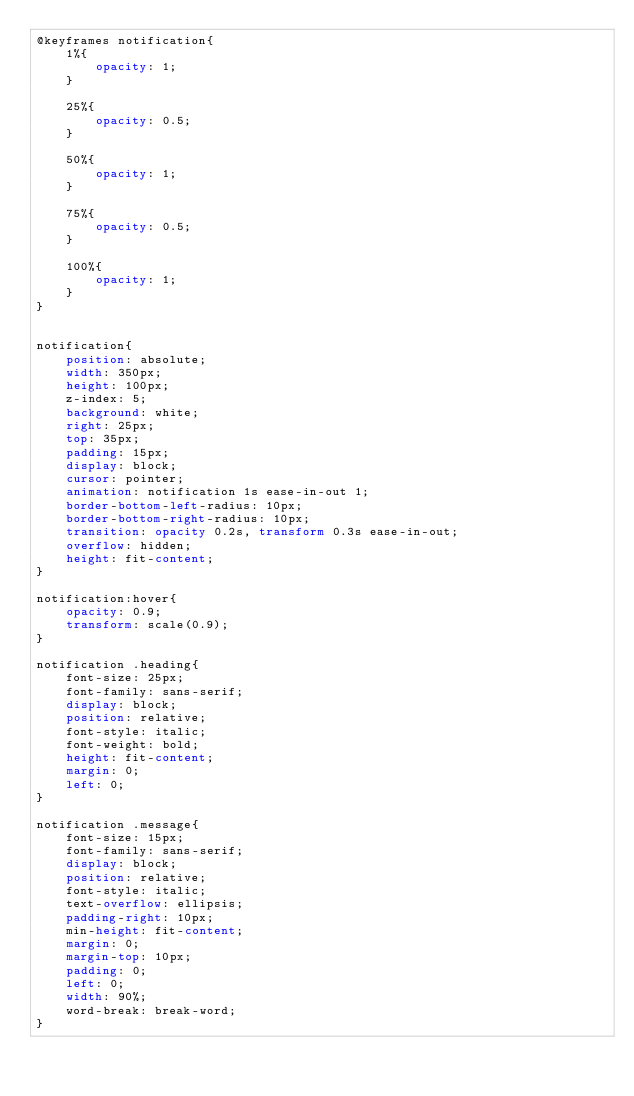Convert code to text. <code><loc_0><loc_0><loc_500><loc_500><_CSS_>@keyframes notification{
    1%{
        opacity: 1;
    }

    25%{
        opacity: 0.5;
    }

    50%{
        opacity: 1;
    }

    75%{
        opacity: 0.5;
    }

    100%{
        opacity: 1;
    }
}


notification{
    position: absolute;
    width: 350px;
    height: 100px;
    z-index: 5;
    background: white;
    right: 25px;
    top: 35px;
    padding: 15px;
    display: block;
    cursor: pointer;
    animation: notification 1s ease-in-out 1;
    border-bottom-left-radius: 10px;
    border-bottom-right-radius: 10px;
    transition: opacity 0.2s, transform 0.3s ease-in-out;
    overflow: hidden;
    height: fit-content;
}

notification:hover{
    opacity: 0.9;
    transform: scale(0.9);
}

notification .heading{
    font-size: 25px;
    font-family: sans-serif;
    display: block;
    position: relative;
    font-style: italic;
    font-weight: bold;
    height: fit-content;
    margin: 0;
    left: 0;
}

notification .message{
    font-size: 15px;
    font-family: sans-serif;
    display: block;
    position: relative;
    font-style: italic;
    text-overflow: ellipsis;
    padding-right: 10px;
    min-height: fit-content;
    margin: 0;
    margin-top: 10px;
    padding: 0;
    left: 0;
    width: 90%;
    word-break: break-word;
}
</code> 